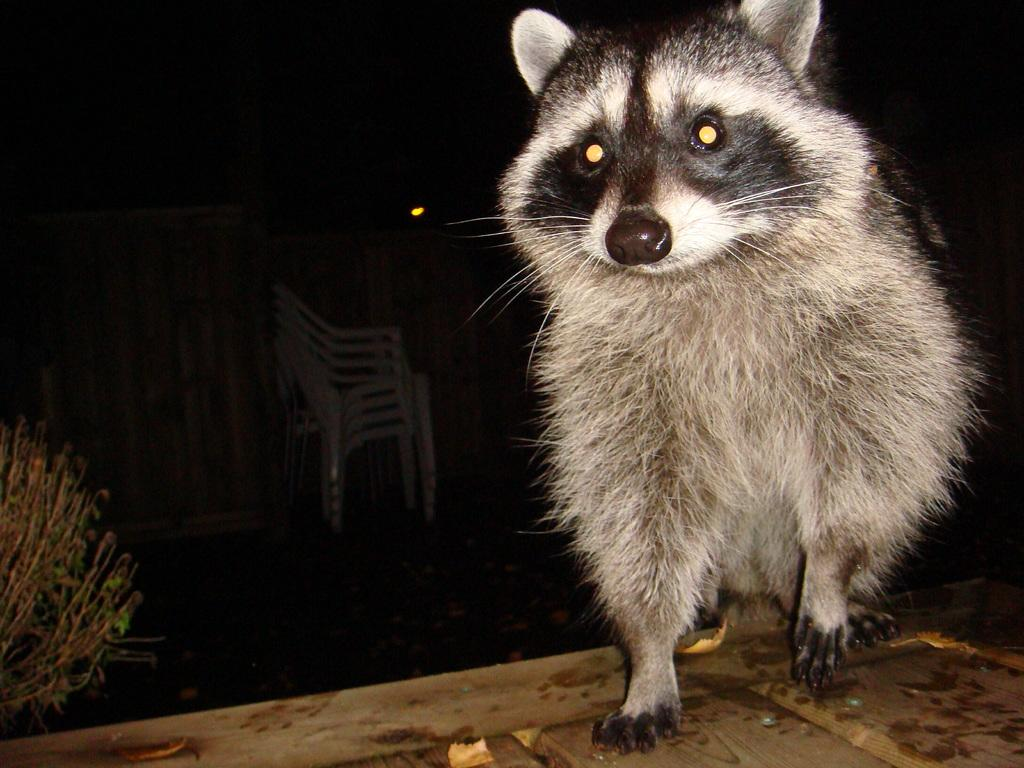What is the main subject on the wooden plank in the image? There is an animal on a wooden plank in the image. What can be seen in the background of the image? There are chairs in the background of the image, stacked one above the other. What type of vegetation is on the left side of the image? There is a plant on the left side of the image. What time of day is it in the image, based on the hour displayed on a clock? There is no clock present in the image, so we cannot determine the time of day based on an hour. 